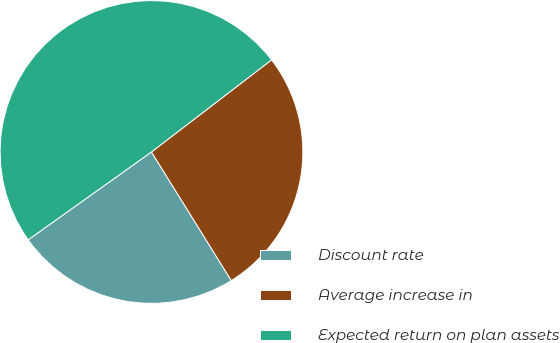<chart> <loc_0><loc_0><loc_500><loc_500><pie_chart><fcel>Discount rate<fcel>Average increase in<fcel>Expected return on plan assets<nl><fcel>23.99%<fcel>26.57%<fcel>49.44%<nl></chart> 